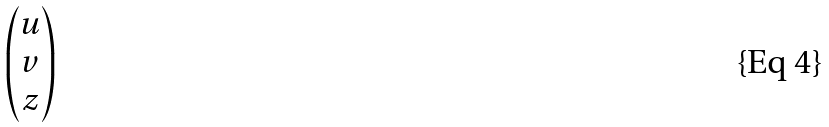<formula> <loc_0><loc_0><loc_500><loc_500>\begin{pmatrix} u \\ v \\ z \end{pmatrix}</formula> 